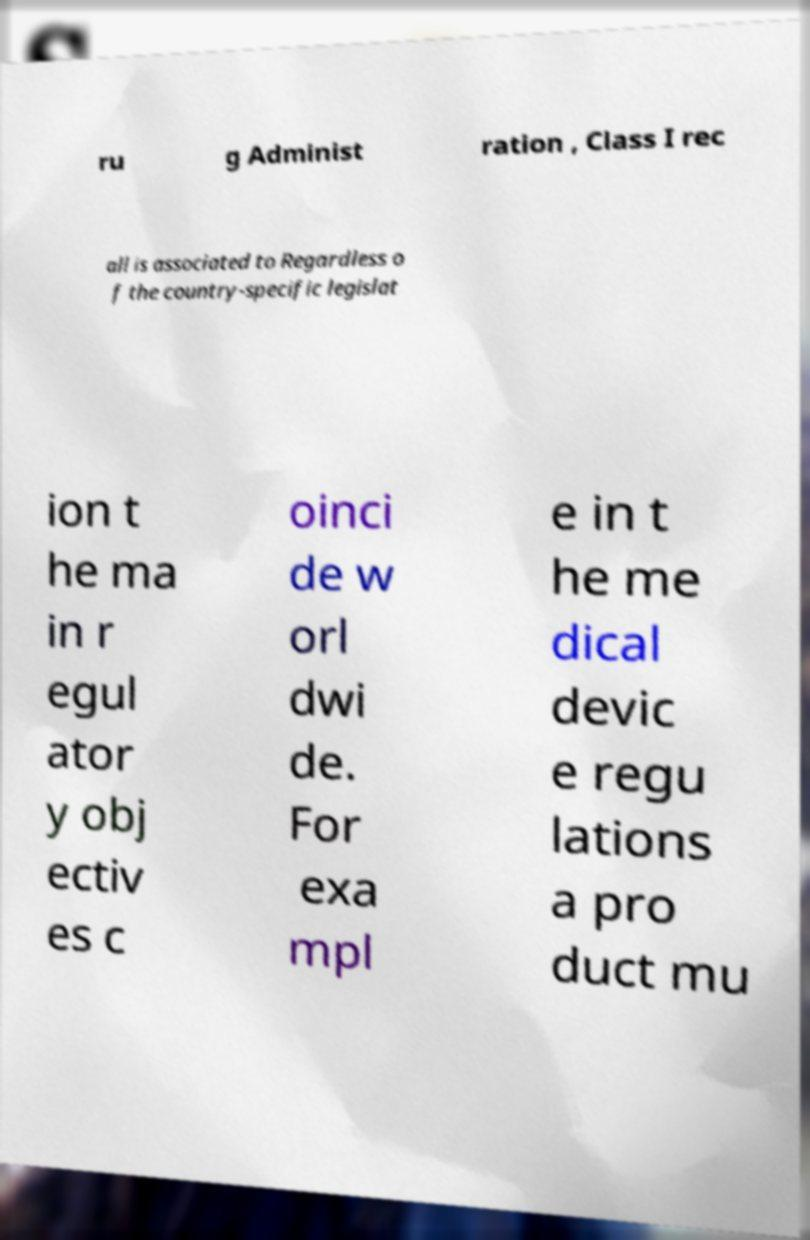Can you accurately transcribe the text from the provided image for me? ru g Administ ration , Class I rec all is associated to Regardless o f the country-specific legislat ion t he ma in r egul ator y obj ectiv es c oinci de w orl dwi de. For exa mpl e in t he me dical devic e regu lations a pro duct mu 